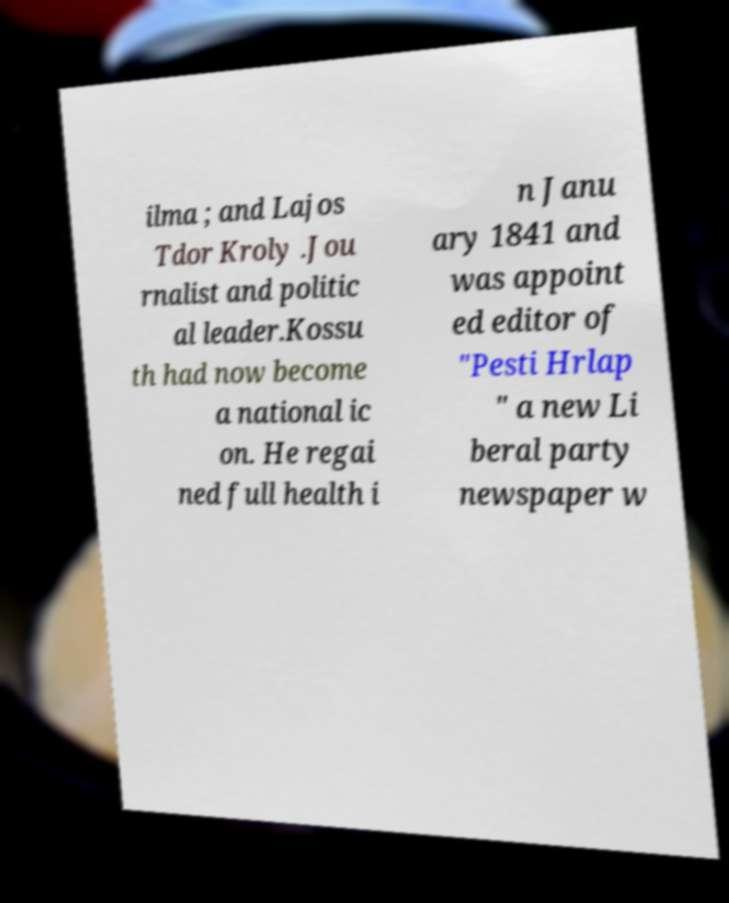Can you read and provide the text displayed in the image?This photo seems to have some interesting text. Can you extract and type it out for me? ilma ; and Lajos Tdor Kroly .Jou rnalist and politic al leader.Kossu th had now become a national ic on. He regai ned full health i n Janu ary 1841 and was appoint ed editor of "Pesti Hrlap " a new Li beral party newspaper w 